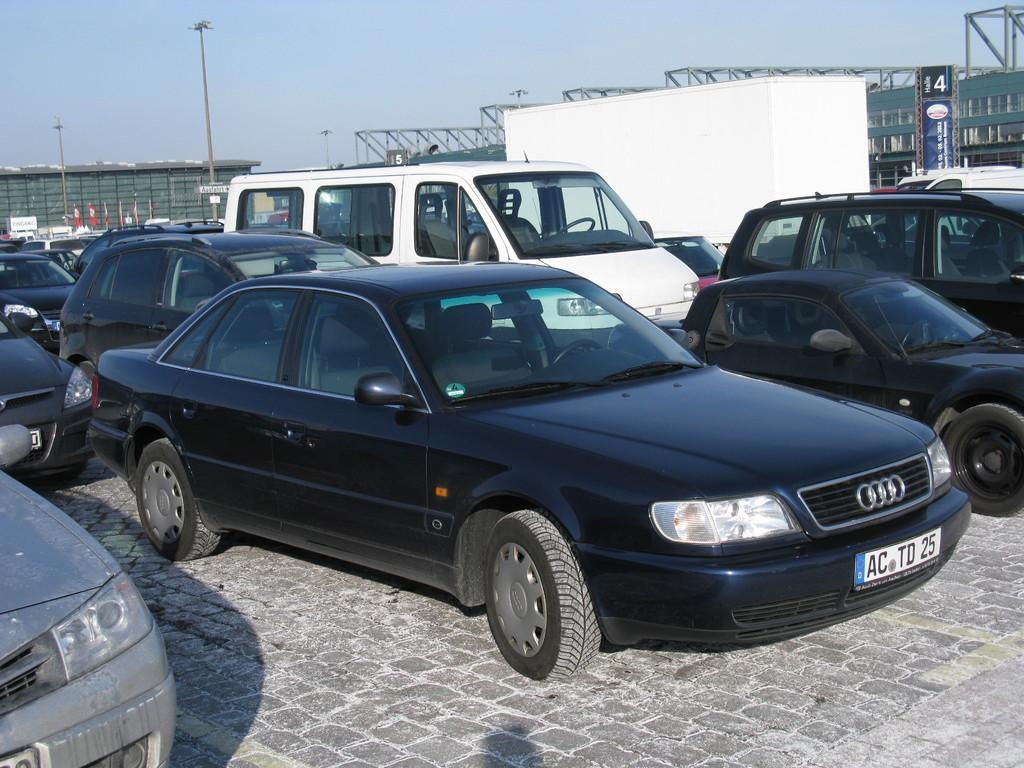Could you give a brief overview of what you see in this image? In this image there are a group of cars and at the bottom there is walkway, and in the background there are some poles, buildings, boards and some other objects. At the top there is sky. 